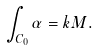<formula> <loc_0><loc_0><loc_500><loc_500>\int _ { C _ { 0 } } \alpha = k M .</formula> 